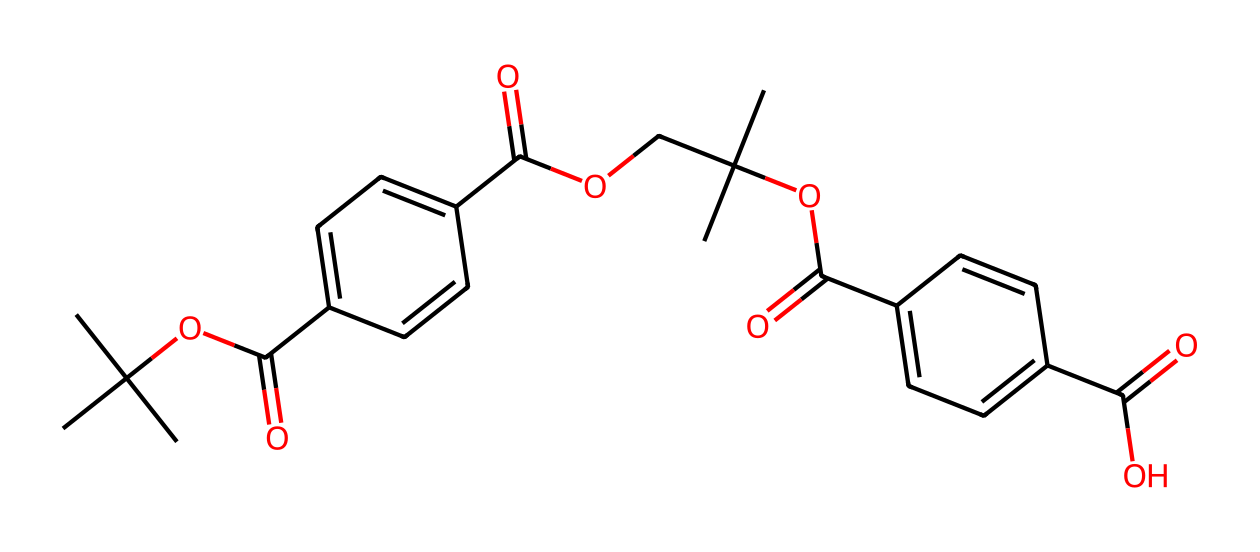What is the predominant functional group in this chemical? The chemical contains multiple ester and carboxylic acid functional groups, indicated by the presence of the carbonyl (C=O) adjacent to an -O- (ether) and -OH (alcohol) group. The structure suggests that esters are the dominant functional group.
Answer: ester How many aromatic rings are present in the structure? The structure includes two distinct phenolic rings, characterized by the presence of alternating double bonds within a six-membered carbon ring system. Counting these features reveals two aromatic rings.
Answer: 2 What type of polymer is this chemical structure derived from? The chemical's structure aligns closely with that of polyethylene terephthalate (PET), a common thermoplastic polyester used in fibers and containers, indicating that it is derived from PET.
Answer: polyester How many carbon atoms are in the molecule? By analyzing the SMILES representation, we can count the number of carbon atoms present. In this case, the structure contains a total of twenty carbon atoms when systematically identifying each carbon symbol in the sequence.
Answer: 20 What recycling process does this chemical represent? The chemical is a representation of recycled PET, specifically through a process that breaks down and repolymerizes used PET materials, indicating a recycling process that turns waste into a reusable form.
Answer: mechanical recycling 